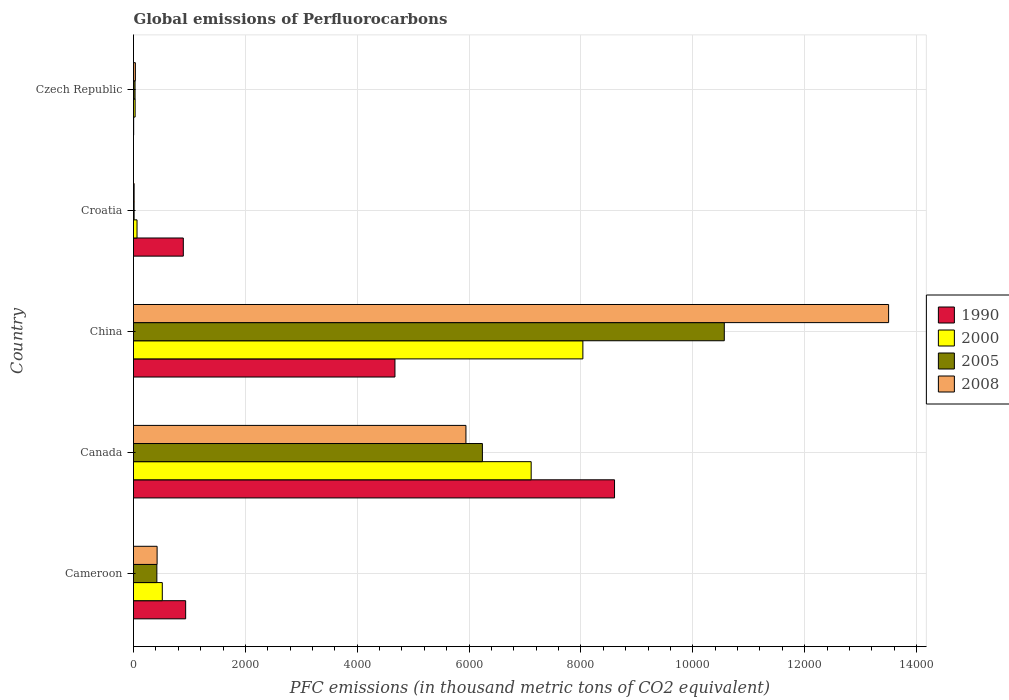Are the number of bars per tick equal to the number of legend labels?
Your answer should be compact. Yes. Are the number of bars on each tick of the Y-axis equal?
Make the answer very short. Yes. How many bars are there on the 4th tick from the bottom?
Your response must be concise. 4. What is the label of the 1st group of bars from the top?
Your response must be concise. Czech Republic. In how many cases, is the number of bars for a given country not equal to the number of legend labels?
Keep it short and to the point. 0. What is the global emissions of Perfluorocarbons in 2000 in Czech Republic?
Your answer should be very brief. 28.8. Across all countries, what is the maximum global emissions of Perfluorocarbons in 2000?
Your answer should be compact. 8034.4. Across all countries, what is the minimum global emissions of Perfluorocarbons in 2008?
Offer a very short reply. 11. In which country was the global emissions of Perfluorocarbons in 2008 maximum?
Provide a succinct answer. China. In which country was the global emissions of Perfluorocarbons in 2005 minimum?
Provide a short and direct response. Croatia. What is the total global emissions of Perfluorocarbons in 2008 in the graph?
Your response must be concise. 1.99e+04. What is the difference between the global emissions of Perfluorocarbons in 2000 in Canada and that in Croatia?
Provide a succinct answer. 7046.9. What is the difference between the global emissions of Perfluorocarbons in 2000 in Czech Republic and the global emissions of Perfluorocarbons in 2005 in Cameroon?
Your answer should be compact. -388.7. What is the average global emissions of Perfluorocarbons in 1990 per country?
Your response must be concise. 3020.06. What is the difference between the global emissions of Perfluorocarbons in 2005 and global emissions of Perfluorocarbons in 2008 in Czech Republic?
Ensure brevity in your answer.  -5.8. What is the ratio of the global emissions of Perfluorocarbons in 2005 in Cameroon to that in China?
Make the answer very short. 0.04. Is the global emissions of Perfluorocarbons in 2005 in China less than that in Croatia?
Make the answer very short. No. What is the difference between the highest and the second highest global emissions of Perfluorocarbons in 2000?
Ensure brevity in your answer.  924.5. What is the difference between the highest and the lowest global emissions of Perfluorocarbons in 2000?
Keep it short and to the point. 8005.6. What does the 4th bar from the bottom in Cameroon represents?
Your answer should be very brief. 2008. How many countries are there in the graph?
Keep it short and to the point. 5. What is the difference between two consecutive major ticks on the X-axis?
Ensure brevity in your answer.  2000. Are the values on the major ticks of X-axis written in scientific E-notation?
Give a very brief answer. No. Does the graph contain any zero values?
Offer a terse response. No. Does the graph contain grids?
Ensure brevity in your answer.  Yes. How many legend labels are there?
Make the answer very short. 4. How are the legend labels stacked?
Offer a terse response. Vertical. What is the title of the graph?
Offer a very short reply. Global emissions of Perfluorocarbons. Does "2002" appear as one of the legend labels in the graph?
Give a very brief answer. No. What is the label or title of the X-axis?
Offer a very short reply. PFC emissions (in thousand metric tons of CO2 equivalent). What is the label or title of the Y-axis?
Keep it short and to the point. Country. What is the PFC emissions (in thousand metric tons of CO2 equivalent) in 1990 in Cameroon?
Offer a terse response. 932.3. What is the PFC emissions (in thousand metric tons of CO2 equivalent) of 2000 in Cameroon?
Your answer should be compact. 514.7. What is the PFC emissions (in thousand metric tons of CO2 equivalent) in 2005 in Cameroon?
Your answer should be compact. 417.5. What is the PFC emissions (in thousand metric tons of CO2 equivalent) in 2008 in Cameroon?
Make the answer very short. 422.1. What is the PFC emissions (in thousand metric tons of CO2 equivalent) of 1990 in Canada?
Make the answer very short. 8600.3. What is the PFC emissions (in thousand metric tons of CO2 equivalent) in 2000 in Canada?
Keep it short and to the point. 7109.9. What is the PFC emissions (in thousand metric tons of CO2 equivalent) in 2005 in Canada?
Your answer should be very brief. 6238. What is the PFC emissions (in thousand metric tons of CO2 equivalent) of 2008 in Canada?
Your answer should be compact. 5943.7. What is the PFC emissions (in thousand metric tons of CO2 equivalent) of 1990 in China?
Your answer should be compact. 4674.5. What is the PFC emissions (in thousand metric tons of CO2 equivalent) of 2000 in China?
Offer a terse response. 8034.4. What is the PFC emissions (in thousand metric tons of CO2 equivalent) of 2005 in China?
Make the answer very short. 1.06e+04. What is the PFC emissions (in thousand metric tons of CO2 equivalent) of 2008 in China?
Make the answer very short. 1.35e+04. What is the PFC emissions (in thousand metric tons of CO2 equivalent) in 1990 in Croatia?
Make the answer very short. 890.4. What is the PFC emissions (in thousand metric tons of CO2 equivalent) in 2005 in Croatia?
Provide a succinct answer. 10.9. What is the PFC emissions (in thousand metric tons of CO2 equivalent) of 2000 in Czech Republic?
Offer a terse response. 28.8. What is the PFC emissions (in thousand metric tons of CO2 equivalent) in 2005 in Czech Republic?
Ensure brevity in your answer.  27.5. What is the PFC emissions (in thousand metric tons of CO2 equivalent) in 2008 in Czech Republic?
Your answer should be very brief. 33.3. Across all countries, what is the maximum PFC emissions (in thousand metric tons of CO2 equivalent) of 1990?
Offer a very short reply. 8600.3. Across all countries, what is the maximum PFC emissions (in thousand metric tons of CO2 equivalent) of 2000?
Give a very brief answer. 8034.4. Across all countries, what is the maximum PFC emissions (in thousand metric tons of CO2 equivalent) of 2005?
Make the answer very short. 1.06e+04. Across all countries, what is the maximum PFC emissions (in thousand metric tons of CO2 equivalent) in 2008?
Make the answer very short. 1.35e+04. Across all countries, what is the minimum PFC emissions (in thousand metric tons of CO2 equivalent) of 1990?
Your response must be concise. 2.8. Across all countries, what is the minimum PFC emissions (in thousand metric tons of CO2 equivalent) of 2000?
Give a very brief answer. 28.8. Across all countries, what is the minimum PFC emissions (in thousand metric tons of CO2 equivalent) in 2005?
Keep it short and to the point. 10.9. Across all countries, what is the minimum PFC emissions (in thousand metric tons of CO2 equivalent) of 2008?
Make the answer very short. 11. What is the total PFC emissions (in thousand metric tons of CO2 equivalent) in 1990 in the graph?
Your answer should be very brief. 1.51e+04. What is the total PFC emissions (in thousand metric tons of CO2 equivalent) of 2000 in the graph?
Keep it short and to the point. 1.58e+04. What is the total PFC emissions (in thousand metric tons of CO2 equivalent) in 2005 in the graph?
Ensure brevity in your answer.  1.73e+04. What is the total PFC emissions (in thousand metric tons of CO2 equivalent) of 2008 in the graph?
Your response must be concise. 1.99e+04. What is the difference between the PFC emissions (in thousand metric tons of CO2 equivalent) in 1990 in Cameroon and that in Canada?
Provide a short and direct response. -7668. What is the difference between the PFC emissions (in thousand metric tons of CO2 equivalent) in 2000 in Cameroon and that in Canada?
Your response must be concise. -6595.2. What is the difference between the PFC emissions (in thousand metric tons of CO2 equivalent) of 2005 in Cameroon and that in Canada?
Your answer should be very brief. -5820.5. What is the difference between the PFC emissions (in thousand metric tons of CO2 equivalent) of 2008 in Cameroon and that in Canada?
Your answer should be compact. -5521.6. What is the difference between the PFC emissions (in thousand metric tons of CO2 equivalent) of 1990 in Cameroon and that in China?
Offer a terse response. -3742.2. What is the difference between the PFC emissions (in thousand metric tons of CO2 equivalent) of 2000 in Cameroon and that in China?
Offer a terse response. -7519.7. What is the difference between the PFC emissions (in thousand metric tons of CO2 equivalent) of 2005 in Cameroon and that in China?
Your answer should be very brief. -1.01e+04. What is the difference between the PFC emissions (in thousand metric tons of CO2 equivalent) in 2008 in Cameroon and that in China?
Your response must be concise. -1.31e+04. What is the difference between the PFC emissions (in thousand metric tons of CO2 equivalent) in 1990 in Cameroon and that in Croatia?
Offer a terse response. 41.9. What is the difference between the PFC emissions (in thousand metric tons of CO2 equivalent) in 2000 in Cameroon and that in Croatia?
Keep it short and to the point. 451.7. What is the difference between the PFC emissions (in thousand metric tons of CO2 equivalent) in 2005 in Cameroon and that in Croatia?
Provide a succinct answer. 406.6. What is the difference between the PFC emissions (in thousand metric tons of CO2 equivalent) in 2008 in Cameroon and that in Croatia?
Give a very brief answer. 411.1. What is the difference between the PFC emissions (in thousand metric tons of CO2 equivalent) of 1990 in Cameroon and that in Czech Republic?
Make the answer very short. 929.5. What is the difference between the PFC emissions (in thousand metric tons of CO2 equivalent) in 2000 in Cameroon and that in Czech Republic?
Give a very brief answer. 485.9. What is the difference between the PFC emissions (in thousand metric tons of CO2 equivalent) in 2005 in Cameroon and that in Czech Republic?
Provide a succinct answer. 390. What is the difference between the PFC emissions (in thousand metric tons of CO2 equivalent) of 2008 in Cameroon and that in Czech Republic?
Make the answer very short. 388.8. What is the difference between the PFC emissions (in thousand metric tons of CO2 equivalent) in 1990 in Canada and that in China?
Keep it short and to the point. 3925.8. What is the difference between the PFC emissions (in thousand metric tons of CO2 equivalent) of 2000 in Canada and that in China?
Offer a terse response. -924.5. What is the difference between the PFC emissions (in thousand metric tons of CO2 equivalent) of 2005 in Canada and that in China?
Your answer should be very brief. -4324.8. What is the difference between the PFC emissions (in thousand metric tons of CO2 equivalent) of 2008 in Canada and that in China?
Ensure brevity in your answer.  -7556.9. What is the difference between the PFC emissions (in thousand metric tons of CO2 equivalent) in 1990 in Canada and that in Croatia?
Ensure brevity in your answer.  7709.9. What is the difference between the PFC emissions (in thousand metric tons of CO2 equivalent) in 2000 in Canada and that in Croatia?
Offer a very short reply. 7046.9. What is the difference between the PFC emissions (in thousand metric tons of CO2 equivalent) of 2005 in Canada and that in Croatia?
Give a very brief answer. 6227.1. What is the difference between the PFC emissions (in thousand metric tons of CO2 equivalent) of 2008 in Canada and that in Croatia?
Keep it short and to the point. 5932.7. What is the difference between the PFC emissions (in thousand metric tons of CO2 equivalent) of 1990 in Canada and that in Czech Republic?
Your response must be concise. 8597.5. What is the difference between the PFC emissions (in thousand metric tons of CO2 equivalent) in 2000 in Canada and that in Czech Republic?
Your response must be concise. 7081.1. What is the difference between the PFC emissions (in thousand metric tons of CO2 equivalent) in 2005 in Canada and that in Czech Republic?
Offer a terse response. 6210.5. What is the difference between the PFC emissions (in thousand metric tons of CO2 equivalent) of 2008 in Canada and that in Czech Republic?
Offer a terse response. 5910.4. What is the difference between the PFC emissions (in thousand metric tons of CO2 equivalent) in 1990 in China and that in Croatia?
Offer a terse response. 3784.1. What is the difference between the PFC emissions (in thousand metric tons of CO2 equivalent) of 2000 in China and that in Croatia?
Your answer should be very brief. 7971.4. What is the difference between the PFC emissions (in thousand metric tons of CO2 equivalent) of 2005 in China and that in Croatia?
Offer a terse response. 1.06e+04. What is the difference between the PFC emissions (in thousand metric tons of CO2 equivalent) in 2008 in China and that in Croatia?
Give a very brief answer. 1.35e+04. What is the difference between the PFC emissions (in thousand metric tons of CO2 equivalent) in 1990 in China and that in Czech Republic?
Your answer should be compact. 4671.7. What is the difference between the PFC emissions (in thousand metric tons of CO2 equivalent) in 2000 in China and that in Czech Republic?
Give a very brief answer. 8005.6. What is the difference between the PFC emissions (in thousand metric tons of CO2 equivalent) of 2005 in China and that in Czech Republic?
Your answer should be compact. 1.05e+04. What is the difference between the PFC emissions (in thousand metric tons of CO2 equivalent) in 2008 in China and that in Czech Republic?
Your answer should be compact. 1.35e+04. What is the difference between the PFC emissions (in thousand metric tons of CO2 equivalent) in 1990 in Croatia and that in Czech Republic?
Your response must be concise. 887.6. What is the difference between the PFC emissions (in thousand metric tons of CO2 equivalent) of 2000 in Croatia and that in Czech Republic?
Offer a very short reply. 34.2. What is the difference between the PFC emissions (in thousand metric tons of CO2 equivalent) of 2005 in Croatia and that in Czech Republic?
Make the answer very short. -16.6. What is the difference between the PFC emissions (in thousand metric tons of CO2 equivalent) of 2008 in Croatia and that in Czech Republic?
Your answer should be compact. -22.3. What is the difference between the PFC emissions (in thousand metric tons of CO2 equivalent) in 1990 in Cameroon and the PFC emissions (in thousand metric tons of CO2 equivalent) in 2000 in Canada?
Make the answer very short. -6177.6. What is the difference between the PFC emissions (in thousand metric tons of CO2 equivalent) of 1990 in Cameroon and the PFC emissions (in thousand metric tons of CO2 equivalent) of 2005 in Canada?
Your answer should be compact. -5305.7. What is the difference between the PFC emissions (in thousand metric tons of CO2 equivalent) of 1990 in Cameroon and the PFC emissions (in thousand metric tons of CO2 equivalent) of 2008 in Canada?
Offer a terse response. -5011.4. What is the difference between the PFC emissions (in thousand metric tons of CO2 equivalent) of 2000 in Cameroon and the PFC emissions (in thousand metric tons of CO2 equivalent) of 2005 in Canada?
Keep it short and to the point. -5723.3. What is the difference between the PFC emissions (in thousand metric tons of CO2 equivalent) of 2000 in Cameroon and the PFC emissions (in thousand metric tons of CO2 equivalent) of 2008 in Canada?
Give a very brief answer. -5429. What is the difference between the PFC emissions (in thousand metric tons of CO2 equivalent) of 2005 in Cameroon and the PFC emissions (in thousand metric tons of CO2 equivalent) of 2008 in Canada?
Your answer should be compact. -5526.2. What is the difference between the PFC emissions (in thousand metric tons of CO2 equivalent) in 1990 in Cameroon and the PFC emissions (in thousand metric tons of CO2 equivalent) in 2000 in China?
Offer a terse response. -7102.1. What is the difference between the PFC emissions (in thousand metric tons of CO2 equivalent) of 1990 in Cameroon and the PFC emissions (in thousand metric tons of CO2 equivalent) of 2005 in China?
Keep it short and to the point. -9630.5. What is the difference between the PFC emissions (in thousand metric tons of CO2 equivalent) of 1990 in Cameroon and the PFC emissions (in thousand metric tons of CO2 equivalent) of 2008 in China?
Provide a short and direct response. -1.26e+04. What is the difference between the PFC emissions (in thousand metric tons of CO2 equivalent) of 2000 in Cameroon and the PFC emissions (in thousand metric tons of CO2 equivalent) of 2005 in China?
Your response must be concise. -1.00e+04. What is the difference between the PFC emissions (in thousand metric tons of CO2 equivalent) of 2000 in Cameroon and the PFC emissions (in thousand metric tons of CO2 equivalent) of 2008 in China?
Keep it short and to the point. -1.30e+04. What is the difference between the PFC emissions (in thousand metric tons of CO2 equivalent) of 2005 in Cameroon and the PFC emissions (in thousand metric tons of CO2 equivalent) of 2008 in China?
Keep it short and to the point. -1.31e+04. What is the difference between the PFC emissions (in thousand metric tons of CO2 equivalent) in 1990 in Cameroon and the PFC emissions (in thousand metric tons of CO2 equivalent) in 2000 in Croatia?
Offer a very short reply. 869.3. What is the difference between the PFC emissions (in thousand metric tons of CO2 equivalent) of 1990 in Cameroon and the PFC emissions (in thousand metric tons of CO2 equivalent) of 2005 in Croatia?
Provide a succinct answer. 921.4. What is the difference between the PFC emissions (in thousand metric tons of CO2 equivalent) in 1990 in Cameroon and the PFC emissions (in thousand metric tons of CO2 equivalent) in 2008 in Croatia?
Your answer should be compact. 921.3. What is the difference between the PFC emissions (in thousand metric tons of CO2 equivalent) in 2000 in Cameroon and the PFC emissions (in thousand metric tons of CO2 equivalent) in 2005 in Croatia?
Give a very brief answer. 503.8. What is the difference between the PFC emissions (in thousand metric tons of CO2 equivalent) of 2000 in Cameroon and the PFC emissions (in thousand metric tons of CO2 equivalent) of 2008 in Croatia?
Your response must be concise. 503.7. What is the difference between the PFC emissions (in thousand metric tons of CO2 equivalent) of 2005 in Cameroon and the PFC emissions (in thousand metric tons of CO2 equivalent) of 2008 in Croatia?
Keep it short and to the point. 406.5. What is the difference between the PFC emissions (in thousand metric tons of CO2 equivalent) of 1990 in Cameroon and the PFC emissions (in thousand metric tons of CO2 equivalent) of 2000 in Czech Republic?
Provide a short and direct response. 903.5. What is the difference between the PFC emissions (in thousand metric tons of CO2 equivalent) of 1990 in Cameroon and the PFC emissions (in thousand metric tons of CO2 equivalent) of 2005 in Czech Republic?
Provide a succinct answer. 904.8. What is the difference between the PFC emissions (in thousand metric tons of CO2 equivalent) of 1990 in Cameroon and the PFC emissions (in thousand metric tons of CO2 equivalent) of 2008 in Czech Republic?
Keep it short and to the point. 899. What is the difference between the PFC emissions (in thousand metric tons of CO2 equivalent) in 2000 in Cameroon and the PFC emissions (in thousand metric tons of CO2 equivalent) in 2005 in Czech Republic?
Your response must be concise. 487.2. What is the difference between the PFC emissions (in thousand metric tons of CO2 equivalent) of 2000 in Cameroon and the PFC emissions (in thousand metric tons of CO2 equivalent) of 2008 in Czech Republic?
Your response must be concise. 481.4. What is the difference between the PFC emissions (in thousand metric tons of CO2 equivalent) of 2005 in Cameroon and the PFC emissions (in thousand metric tons of CO2 equivalent) of 2008 in Czech Republic?
Make the answer very short. 384.2. What is the difference between the PFC emissions (in thousand metric tons of CO2 equivalent) in 1990 in Canada and the PFC emissions (in thousand metric tons of CO2 equivalent) in 2000 in China?
Provide a succinct answer. 565.9. What is the difference between the PFC emissions (in thousand metric tons of CO2 equivalent) of 1990 in Canada and the PFC emissions (in thousand metric tons of CO2 equivalent) of 2005 in China?
Keep it short and to the point. -1962.5. What is the difference between the PFC emissions (in thousand metric tons of CO2 equivalent) in 1990 in Canada and the PFC emissions (in thousand metric tons of CO2 equivalent) in 2008 in China?
Offer a very short reply. -4900.3. What is the difference between the PFC emissions (in thousand metric tons of CO2 equivalent) in 2000 in Canada and the PFC emissions (in thousand metric tons of CO2 equivalent) in 2005 in China?
Your answer should be very brief. -3452.9. What is the difference between the PFC emissions (in thousand metric tons of CO2 equivalent) of 2000 in Canada and the PFC emissions (in thousand metric tons of CO2 equivalent) of 2008 in China?
Provide a short and direct response. -6390.7. What is the difference between the PFC emissions (in thousand metric tons of CO2 equivalent) of 2005 in Canada and the PFC emissions (in thousand metric tons of CO2 equivalent) of 2008 in China?
Provide a short and direct response. -7262.6. What is the difference between the PFC emissions (in thousand metric tons of CO2 equivalent) in 1990 in Canada and the PFC emissions (in thousand metric tons of CO2 equivalent) in 2000 in Croatia?
Your answer should be compact. 8537.3. What is the difference between the PFC emissions (in thousand metric tons of CO2 equivalent) in 1990 in Canada and the PFC emissions (in thousand metric tons of CO2 equivalent) in 2005 in Croatia?
Your response must be concise. 8589.4. What is the difference between the PFC emissions (in thousand metric tons of CO2 equivalent) of 1990 in Canada and the PFC emissions (in thousand metric tons of CO2 equivalent) of 2008 in Croatia?
Your response must be concise. 8589.3. What is the difference between the PFC emissions (in thousand metric tons of CO2 equivalent) of 2000 in Canada and the PFC emissions (in thousand metric tons of CO2 equivalent) of 2005 in Croatia?
Your answer should be very brief. 7099. What is the difference between the PFC emissions (in thousand metric tons of CO2 equivalent) in 2000 in Canada and the PFC emissions (in thousand metric tons of CO2 equivalent) in 2008 in Croatia?
Provide a succinct answer. 7098.9. What is the difference between the PFC emissions (in thousand metric tons of CO2 equivalent) in 2005 in Canada and the PFC emissions (in thousand metric tons of CO2 equivalent) in 2008 in Croatia?
Ensure brevity in your answer.  6227. What is the difference between the PFC emissions (in thousand metric tons of CO2 equivalent) in 1990 in Canada and the PFC emissions (in thousand metric tons of CO2 equivalent) in 2000 in Czech Republic?
Give a very brief answer. 8571.5. What is the difference between the PFC emissions (in thousand metric tons of CO2 equivalent) of 1990 in Canada and the PFC emissions (in thousand metric tons of CO2 equivalent) of 2005 in Czech Republic?
Offer a terse response. 8572.8. What is the difference between the PFC emissions (in thousand metric tons of CO2 equivalent) of 1990 in Canada and the PFC emissions (in thousand metric tons of CO2 equivalent) of 2008 in Czech Republic?
Your answer should be very brief. 8567. What is the difference between the PFC emissions (in thousand metric tons of CO2 equivalent) in 2000 in Canada and the PFC emissions (in thousand metric tons of CO2 equivalent) in 2005 in Czech Republic?
Offer a terse response. 7082.4. What is the difference between the PFC emissions (in thousand metric tons of CO2 equivalent) of 2000 in Canada and the PFC emissions (in thousand metric tons of CO2 equivalent) of 2008 in Czech Republic?
Give a very brief answer. 7076.6. What is the difference between the PFC emissions (in thousand metric tons of CO2 equivalent) in 2005 in Canada and the PFC emissions (in thousand metric tons of CO2 equivalent) in 2008 in Czech Republic?
Offer a terse response. 6204.7. What is the difference between the PFC emissions (in thousand metric tons of CO2 equivalent) of 1990 in China and the PFC emissions (in thousand metric tons of CO2 equivalent) of 2000 in Croatia?
Provide a short and direct response. 4611.5. What is the difference between the PFC emissions (in thousand metric tons of CO2 equivalent) in 1990 in China and the PFC emissions (in thousand metric tons of CO2 equivalent) in 2005 in Croatia?
Offer a terse response. 4663.6. What is the difference between the PFC emissions (in thousand metric tons of CO2 equivalent) in 1990 in China and the PFC emissions (in thousand metric tons of CO2 equivalent) in 2008 in Croatia?
Your answer should be very brief. 4663.5. What is the difference between the PFC emissions (in thousand metric tons of CO2 equivalent) of 2000 in China and the PFC emissions (in thousand metric tons of CO2 equivalent) of 2005 in Croatia?
Your response must be concise. 8023.5. What is the difference between the PFC emissions (in thousand metric tons of CO2 equivalent) in 2000 in China and the PFC emissions (in thousand metric tons of CO2 equivalent) in 2008 in Croatia?
Your answer should be compact. 8023.4. What is the difference between the PFC emissions (in thousand metric tons of CO2 equivalent) of 2005 in China and the PFC emissions (in thousand metric tons of CO2 equivalent) of 2008 in Croatia?
Make the answer very short. 1.06e+04. What is the difference between the PFC emissions (in thousand metric tons of CO2 equivalent) of 1990 in China and the PFC emissions (in thousand metric tons of CO2 equivalent) of 2000 in Czech Republic?
Your answer should be compact. 4645.7. What is the difference between the PFC emissions (in thousand metric tons of CO2 equivalent) in 1990 in China and the PFC emissions (in thousand metric tons of CO2 equivalent) in 2005 in Czech Republic?
Provide a succinct answer. 4647. What is the difference between the PFC emissions (in thousand metric tons of CO2 equivalent) of 1990 in China and the PFC emissions (in thousand metric tons of CO2 equivalent) of 2008 in Czech Republic?
Offer a very short reply. 4641.2. What is the difference between the PFC emissions (in thousand metric tons of CO2 equivalent) in 2000 in China and the PFC emissions (in thousand metric tons of CO2 equivalent) in 2005 in Czech Republic?
Your answer should be compact. 8006.9. What is the difference between the PFC emissions (in thousand metric tons of CO2 equivalent) of 2000 in China and the PFC emissions (in thousand metric tons of CO2 equivalent) of 2008 in Czech Republic?
Give a very brief answer. 8001.1. What is the difference between the PFC emissions (in thousand metric tons of CO2 equivalent) of 2005 in China and the PFC emissions (in thousand metric tons of CO2 equivalent) of 2008 in Czech Republic?
Provide a succinct answer. 1.05e+04. What is the difference between the PFC emissions (in thousand metric tons of CO2 equivalent) of 1990 in Croatia and the PFC emissions (in thousand metric tons of CO2 equivalent) of 2000 in Czech Republic?
Offer a very short reply. 861.6. What is the difference between the PFC emissions (in thousand metric tons of CO2 equivalent) in 1990 in Croatia and the PFC emissions (in thousand metric tons of CO2 equivalent) in 2005 in Czech Republic?
Provide a short and direct response. 862.9. What is the difference between the PFC emissions (in thousand metric tons of CO2 equivalent) of 1990 in Croatia and the PFC emissions (in thousand metric tons of CO2 equivalent) of 2008 in Czech Republic?
Provide a succinct answer. 857.1. What is the difference between the PFC emissions (in thousand metric tons of CO2 equivalent) of 2000 in Croatia and the PFC emissions (in thousand metric tons of CO2 equivalent) of 2005 in Czech Republic?
Your response must be concise. 35.5. What is the difference between the PFC emissions (in thousand metric tons of CO2 equivalent) of 2000 in Croatia and the PFC emissions (in thousand metric tons of CO2 equivalent) of 2008 in Czech Republic?
Make the answer very short. 29.7. What is the difference between the PFC emissions (in thousand metric tons of CO2 equivalent) of 2005 in Croatia and the PFC emissions (in thousand metric tons of CO2 equivalent) of 2008 in Czech Republic?
Provide a succinct answer. -22.4. What is the average PFC emissions (in thousand metric tons of CO2 equivalent) of 1990 per country?
Give a very brief answer. 3020.06. What is the average PFC emissions (in thousand metric tons of CO2 equivalent) of 2000 per country?
Your response must be concise. 3150.16. What is the average PFC emissions (in thousand metric tons of CO2 equivalent) in 2005 per country?
Make the answer very short. 3451.34. What is the average PFC emissions (in thousand metric tons of CO2 equivalent) of 2008 per country?
Your answer should be very brief. 3982.14. What is the difference between the PFC emissions (in thousand metric tons of CO2 equivalent) in 1990 and PFC emissions (in thousand metric tons of CO2 equivalent) in 2000 in Cameroon?
Offer a very short reply. 417.6. What is the difference between the PFC emissions (in thousand metric tons of CO2 equivalent) in 1990 and PFC emissions (in thousand metric tons of CO2 equivalent) in 2005 in Cameroon?
Offer a terse response. 514.8. What is the difference between the PFC emissions (in thousand metric tons of CO2 equivalent) of 1990 and PFC emissions (in thousand metric tons of CO2 equivalent) of 2008 in Cameroon?
Provide a succinct answer. 510.2. What is the difference between the PFC emissions (in thousand metric tons of CO2 equivalent) of 2000 and PFC emissions (in thousand metric tons of CO2 equivalent) of 2005 in Cameroon?
Ensure brevity in your answer.  97.2. What is the difference between the PFC emissions (in thousand metric tons of CO2 equivalent) of 2000 and PFC emissions (in thousand metric tons of CO2 equivalent) of 2008 in Cameroon?
Give a very brief answer. 92.6. What is the difference between the PFC emissions (in thousand metric tons of CO2 equivalent) of 1990 and PFC emissions (in thousand metric tons of CO2 equivalent) of 2000 in Canada?
Provide a succinct answer. 1490.4. What is the difference between the PFC emissions (in thousand metric tons of CO2 equivalent) of 1990 and PFC emissions (in thousand metric tons of CO2 equivalent) of 2005 in Canada?
Offer a very short reply. 2362.3. What is the difference between the PFC emissions (in thousand metric tons of CO2 equivalent) of 1990 and PFC emissions (in thousand metric tons of CO2 equivalent) of 2008 in Canada?
Your answer should be compact. 2656.6. What is the difference between the PFC emissions (in thousand metric tons of CO2 equivalent) in 2000 and PFC emissions (in thousand metric tons of CO2 equivalent) in 2005 in Canada?
Make the answer very short. 871.9. What is the difference between the PFC emissions (in thousand metric tons of CO2 equivalent) of 2000 and PFC emissions (in thousand metric tons of CO2 equivalent) of 2008 in Canada?
Provide a succinct answer. 1166.2. What is the difference between the PFC emissions (in thousand metric tons of CO2 equivalent) of 2005 and PFC emissions (in thousand metric tons of CO2 equivalent) of 2008 in Canada?
Keep it short and to the point. 294.3. What is the difference between the PFC emissions (in thousand metric tons of CO2 equivalent) in 1990 and PFC emissions (in thousand metric tons of CO2 equivalent) in 2000 in China?
Offer a terse response. -3359.9. What is the difference between the PFC emissions (in thousand metric tons of CO2 equivalent) of 1990 and PFC emissions (in thousand metric tons of CO2 equivalent) of 2005 in China?
Your answer should be very brief. -5888.3. What is the difference between the PFC emissions (in thousand metric tons of CO2 equivalent) in 1990 and PFC emissions (in thousand metric tons of CO2 equivalent) in 2008 in China?
Offer a terse response. -8826.1. What is the difference between the PFC emissions (in thousand metric tons of CO2 equivalent) in 2000 and PFC emissions (in thousand metric tons of CO2 equivalent) in 2005 in China?
Provide a succinct answer. -2528.4. What is the difference between the PFC emissions (in thousand metric tons of CO2 equivalent) of 2000 and PFC emissions (in thousand metric tons of CO2 equivalent) of 2008 in China?
Give a very brief answer. -5466.2. What is the difference between the PFC emissions (in thousand metric tons of CO2 equivalent) of 2005 and PFC emissions (in thousand metric tons of CO2 equivalent) of 2008 in China?
Offer a terse response. -2937.8. What is the difference between the PFC emissions (in thousand metric tons of CO2 equivalent) in 1990 and PFC emissions (in thousand metric tons of CO2 equivalent) in 2000 in Croatia?
Provide a short and direct response. 827.4. What is the difference between the PFC emissions (in thousand metric tons of CO2 equivalent) in 1990 and PFC emissions (in thousand metric tons of CO2 equivalent) in 2005 in Croatia?
Provide a short and direct response. 879.5. What is the difference between the PFC emissions (in thousand metric tons of CO2 equivalent) of 1990 and PFC emissions (in thousand metric tons of CO2 equivalent) of 2008 in Croatia?
Provide a short and direct response. 879.4. What is the difference between the PFC emissions (in thousand metric tons of CO2 equivalent) of 2000 and PFC emissions (in thousand metric tons of CO2 equivalent) of 2005 in Croatia?
Provide a succinct answer. 52.1. What is the difference between the PFC emissions (in thousand metric tons of CO2 equivalent) of 1990 and PFC emissions (in thousand metric tons of CO2 equivalent) of 2005 in Czech Republic?
Give a very brief answer. -24.7. What is the difference between the PFC emissions (in thousand metric tons of CO2 equivalent) of 1990 and PFC emissions (in thousand metric tons of CO2 equivalent) of 2008 in Czech Republic?
Provide a succinct answer. -30.5. What is the difference between the PFC emissions (in thousand metric tons of CO2 equivalent) in 2005 and PFC emissions (in thousand metric tons of CO2 equivalent) in 2008 in Czech Republic?
Give a very brief answer. -5.8. What is the ratio of the PFC emissions (in thousand metric tons of CO2 equivalent) in 1990 in Cameroon to that in Canada?
Your answer should be compact. 0.11. What is the ratio of the PFC emissions (in thousand metric tons of CO2 equivalent) in 2000 in Cameroon to that in Canada?
Your answer should be very brief. 0.07. What is the ratio of the PFC emissions (in thousand metric tons of CO2 equivalent) in 2005 in Cameroon to that in Canada?
Provide a succinct answer. 0.07. What is the ratio of the PFC emissions (in thousand metric tons of CO2 equivalent) of 2008 in Cameroon to that in Canada?
Make the answer very short. 0.07. What is the ratio of the PFC emissions (in thousand metric tons of CO2 equivalent) in 1990 in Cameroon to that in China?
Offer a very short reply. 0.2. What is the ratio of the PFC emissions (in thousand metric tons of CO2 equivalent) in 2000 in Cameroon to that in China?
Provide a short and direct response. 0.06. What is the ratio of the PFC emissions (in thousand metric tons of CO2 equivalent) of 2005 in Cameroon to that in China?
Your answer should be compact. 0.04. What is the ratio of the PFC emissions (in thousand metric tons of CO2 equivalent) in 2008 in Cameroon to that in China?
Provide a short and direct response. 0.03. What is the ratio of the PFC emissions (in thousand metric tons of CO2 equivalent) in 1990 in Cameroon to that in Croatia?
Your response must be concise. 1.05. What is the ratio of the PFC emissions (in thousand metric tons of CO2 equivalent) in 2000 in Cameroon to that in Croatia?
Provide a short and direct response. 8.17. What is the ratio of the PFC emissions (in thousand metric tons of CO2 equivalent) in 2005 in Cameroon to that in Croatia?
Keep it short and to the point. 38.3. What is the ratio of the PFC emissions (in thousand metric tons of CO2 equivalent) of 2008 in Cameroon to that in Croatia?
Your answer should be compact. 38.37. What is the ratio of the PFC emissions (in thousand metric tons of CO2 equivalent) in 1990 in Cameroon to that in Czech Republic?
Offer a very short reply. 332.96. What is the ratio of the PFC emissions (in thousand metric tons of CO2 equivalent) in 2000 in Cameroon to that in Czech Republic?
Provide a short and direct response. 17.87. What is the ratio of the PFC emissions (in thousand metric tons of CO2 equivalent) of 2005 in Cameroon to that in Czech Republic?
Keep it short and to the point. 15.18. What is the ratio of the PFC emissions (in thousand metric tons of CO2 equivalent) in 2008 in Cameroon to that in Czech Republic?
Offer a terse response. 12.68. What is the ratio of the PFC emissions (in thousand metric tons of CO2 equivalent) in 1990 in Canada to that in China?
Keep it short and to the point. 1.84. What is the ratio of the PFC emissions (in thousand metric tons of CO2 equivalent) of 2000 in Canada to that in China?
Ensure brevity in your answer.  0.88. What is the ratio of the PFC emissions (in thousand metric tons of CO2 equivalent) of 2005 in Canada to that in China?
Provide a short and direct response. 0.59. What is the ratio of the PFC emissions (in thousand metric tons of CO2 equivalent) of 2008 in Canada to that in China?
Keep it short and to the point. 0.44. What is the ratio of the PFC emissions (in thousand metric tons of CO2 equivalent) of 1990 in Canada to that in Croatia?
Your answer should be compact. 9.66. What is the ratio of the PFC emissions (in thousand metric tons of CO2 equivalent) in 2000 in Canada to that in Croatia?
Ensure brevity in your answer.  112.86. What is the ratio of the PFC emissions (in thousand metric tons of CO2 equivalent) of 2005 in Canada to that in Croatia?
Your answer should be compact. 572.29. What is the ratio of the PFC emissions (in thousand metric tons of CO2 equivalent) in 2008 in Canada to that in Croatia?
Offer a terse response. 540.34. What is the ratio of the PFC emissions (in thousand metric tons of CO2 equivalent) of 1990 in Canada to that in Czech Republic?
Offer a terse response. 3071.54. What is the ratio of the PFC emissions (in thousand metric tons of CO2 equivalent) in 2000 in Canada to that in Czech Republic?
Your answer should be compact. 246.87. What is the ratio of the PFC emissions (in thousand metric tons of CO2 equivalent) in 2005 in Canada to that in Czech Republic?
Keep it short and to the point. 226.84. What is the ratio of the PFC emissions (in thousand metric tons of CO2 equivalent) in 2008 in Canada to that in Czech Republic?
Offer a very short reply. 178.49. What is the ratio of the PFC emissions (in thousand metric tons of CO2 equivalent) in 1990 in China to that in Croatia?
Your response must be concise. 5.25. What is the ratio of the PFC emissions (in thousand metric tons of CO2 equivalent) in 2000 in China to that in Croatia?
Keep it short and to the point. 127.53. What is the ratio of the PFC emissions (in thousand metric tons of CO2 equivalent) of 2005 in China to that in Croatia?
Your answer should be very brief. 969.06. What is the ratio of the PFC emissions (in thousand metric tons of CO2 equivalent) in 2008 in China to that in Croatia?
Your answer should be very brief. 1227.33. What is the ratio of the PFC emissions (in thousand metric tons of CO2 equivalent) in 1990 in China to that in Czech Republic?
Make the answer very short. 1669.46. What is the ratio of the PFC emissions (in thousand metric tons of CO2 equivalent) in 2000 in China to that in Czech Republic?
Your answer should be compact. 278.97. What is the ratio of the PFC emissions (in thousand metric tons of CO2 equivalent) of 2005 in China to that in Czech Republic?
Make the answer very short. 384.1. What is the ratio of the PFC emissions (in thousand metric tons of CO2 equivalent) in 2008 in China to that in Czech Republic?
Give a very brief answer. 405.42. What is the ratio of the PFC emissions (in thousand metric tons of CO2 equivalent) in 1990 in Croatia to that in Czech Republic?
Keep it short and to the point. 318. What is the ratio of the PFC emissions (in thousand metric tons of CO2 equivalent) in 2000 in Croatia to that in Czech Republic?
Give a very brief answer. 2.19. What is the ratio of the PFC emissions (in thousand metric tons of CO2 equivalent) in 2005 in Croatia to that in Czech Republic?
Ensure brevity in your answer.  0.4. What is the ratio of the PFC emissions (in thousand metric tons of CO2 equivalent) of 2008 in Croatia to that in Czech Republic?
Make the answer very short. 0.33. What is the difference between the highest and the second highest PFC emissions (in thousand metric tons of CO2 equivalent) of 1990?
Your answer should be very brief. 3925.8. What is the difference between the highest and the second highest PFC emissions (in thousand metric tons of CO2 equivalent) of 2000?
Ensure brevity in your answer.  924.5. What is the difference between the highest and the second highest PFC emissions (in thousand metric tons of CO2 equivalent) of 2005?
Keep it short and to the point. 4324.8. What is the difference between the highest and the second highest PFC emissions (in thousand metric tons of CO2 equivalent) in 2008?
Your answer should be compact. 7556.9. What is the difference between the highest and the lowest PFC emissions (in thousand metric tons of CO2 equivalent) in 1990?
Provide a short and direct response. 8597.5. What is the difference between the highest and the lowest PFC emissions (in thousand metric tons of CO2 equivalent) in 2000?
Make the answer very short. 8005.6. What is the difference between the highest and the lowest PFC emissions (in thousand metric tons of CO2 equivalent) of 2005?
Ensure brevity in your answer.  1.06e+04. What is the difference between the highest and the lowest PFC emissions (in thousand metric tons of CO2 equivalent) in 2008?
Give a very brief answer. 1.35e+04. 